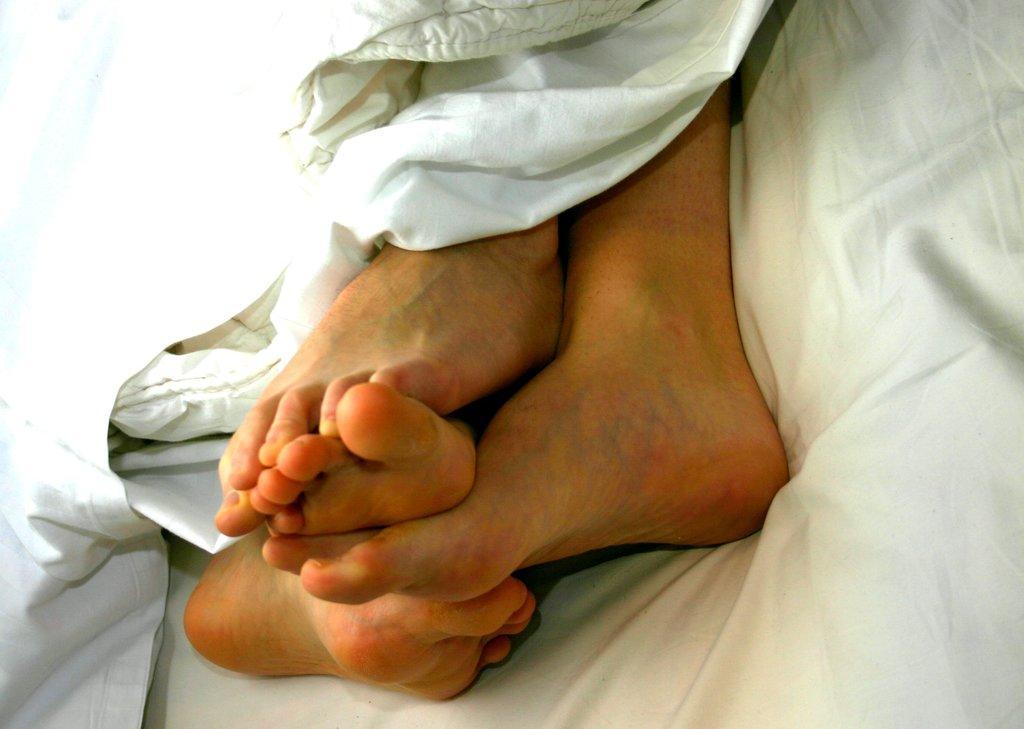In one or two sentences, can you explain what this image depicts? In this image I can see person's legs. I can also see white color clothes. 